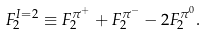<formula> <loc_0><loc_0><loc_500><loc_500>F _ { 2 } ^ { I = 2 } \equiv F _ { 2 } ^ { \pi ^ { + } } + F _ { 2 } ^ { \pi ^ { - } } - 2 F _ { 2 } ^ { \pi ^ { 0 } } .</formula> 